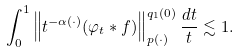Convert formula to latex. <formula><loc_0><loc_0><loc_500><loc_500>\int _ { 0 } ^ { 1 } \left \| t ^ { - \alpha ( \cdot ) } ( \varphi _ { t } \ast f ) \right \| _ { p ( \cdot ) } ^ { q _ { 1 } { ( 0 ) } } \frac { d t } { t } \lesssim 1 .</formula> 